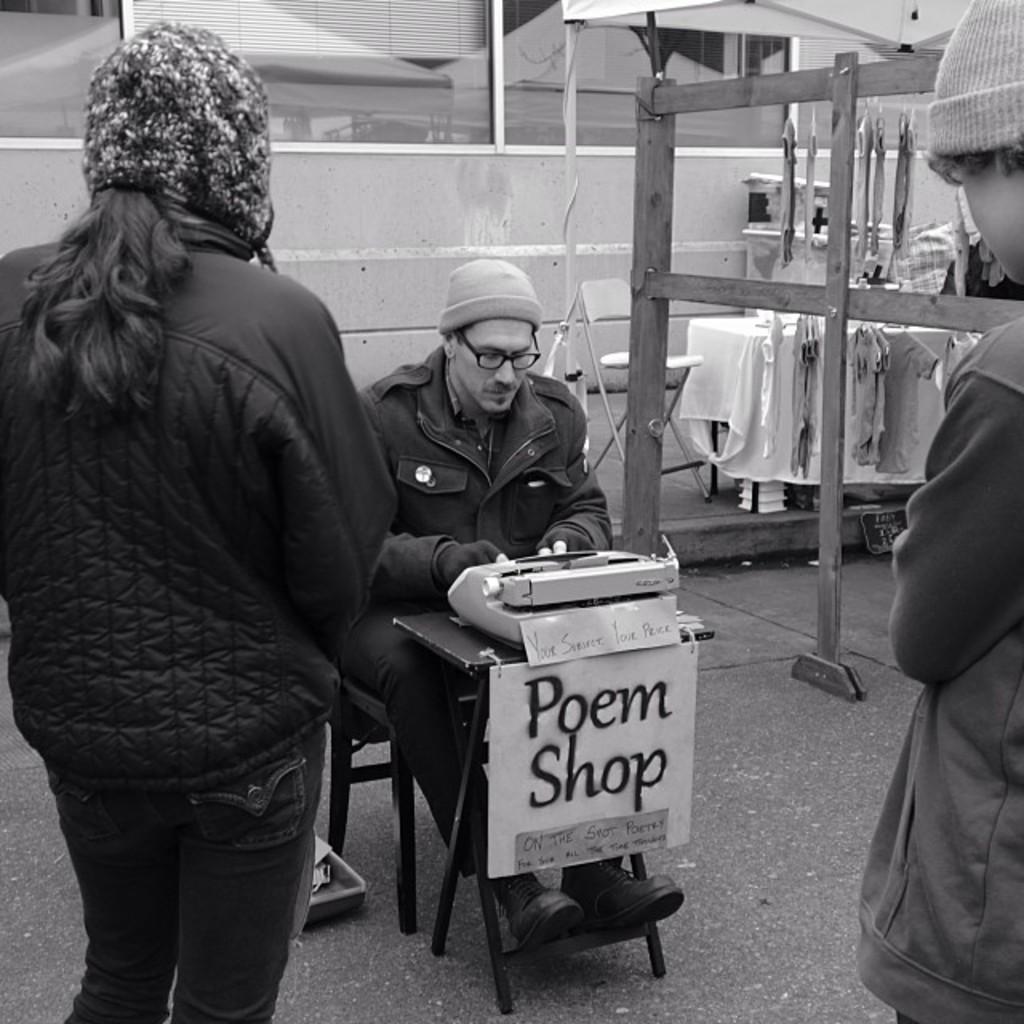How would you summarize this image in a sentence or two? In this picture we can see group of people, few are standing, and a man is seated on the chair, he wore spectacles and a cap, in front of him we can see a typewriter, in the background we can find glass. 